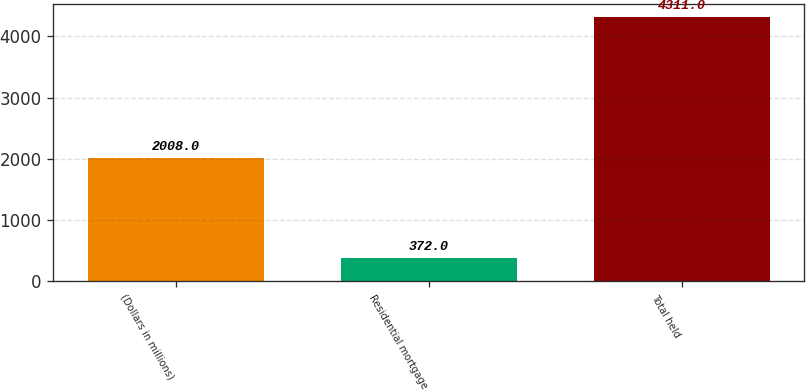<chart> <loc_0><loc_0><loc_500><loc_500><bar_chart><fcel>(Dollars in millions)<fcel>Residential mortgage<fcel>Total held<nl><fcel>2008<fcel>372<fcel>4311<nl></chart> 